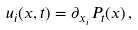<formula> <loc_0><loc_0><loc_500><loc_500>u _ { i } ( x , t ) = \partial _ { x _ { i } } P _ { t } ( x ) \, ,</formula> 